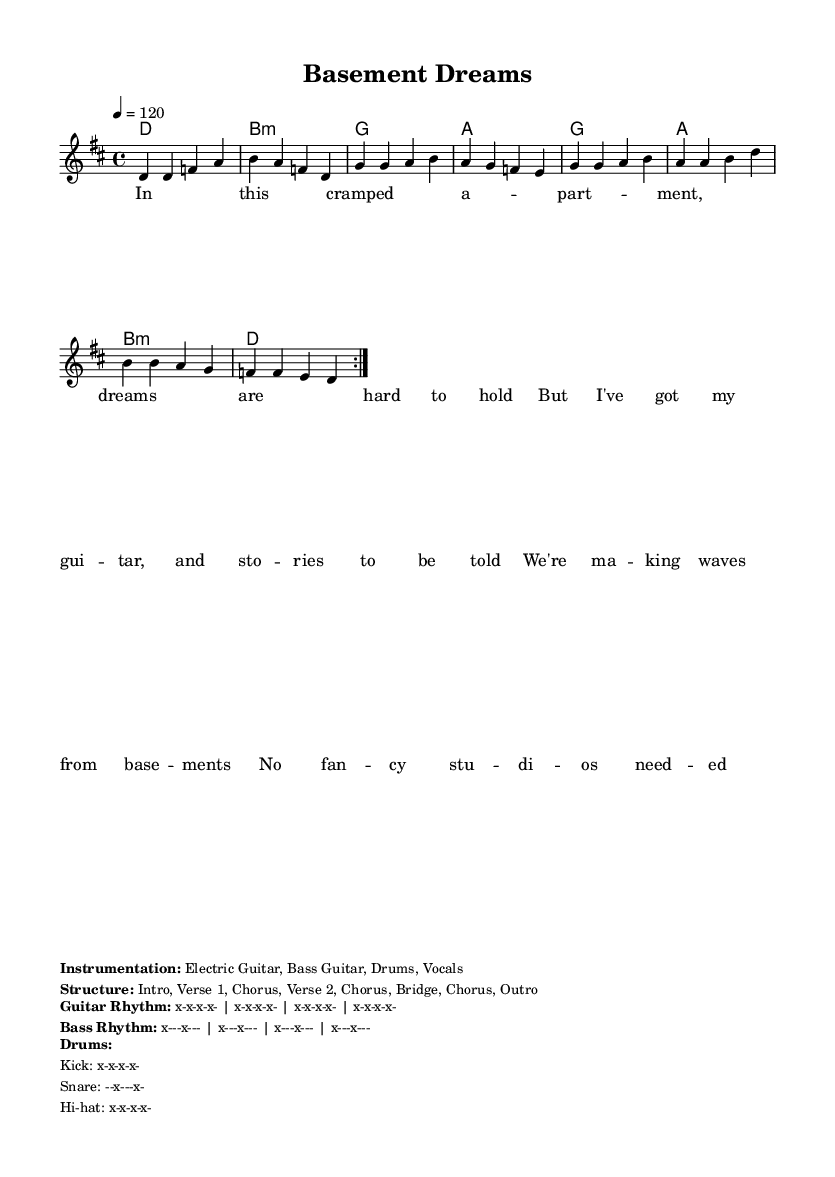What is the key signature of this music? The key signature is D major, indicated by two sharps. The music notation shows a D major scale which helps to identify the key.
Answer: D major What is the time signature of this music? The time signature is 4/4, meaning there are four beats in each measure and the quarter note gets one beat. This is shown at the beginning of the score.
Answer: 4/4 What is the tempo marking of this music? The tempo marking indicates a speed of 120 beats per minute. This is shown in the score with the marking "4 = 120" near the beginning.
Answer: 120 How many verses are in the song structure? The song structure includes two verses according to the breakdown provided in the markup section after the lyrics. It lists "Verse 1" and "Verse 2".
Answer: 2 What instruments are used in this track? The instrumentation includes Electric Guitar, Bass Guitar, Drums, and Vocals as stated in the markup section.
Answer: Electric Guitar, Bass Guitar, Drums, Vocals What rhythmic pattern is noted for the bass? The bass rhythm is indicated as a pattern with a long note followed by rests, described as "x---x---" across the measures. This pattern can be found in the rhythm markup section.
Answer: x---x--- In how many repetitions is the melody section played? The melody is intended to be repeated twice, as noted by "repeat volta 2" in the melody section. The instruction indicates that the melody should cycle two times.
Answer: 2 